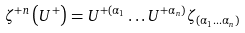<formula> <loc_0><loc_0><loc_500><loc_500>\zeta ^ { + n } \left ( U ^ { + } \right ) = U ^ { + ( \alpha _ { 1 } } \dots U ^ { + \alpha _ { n } ) } \zeta _ { \left ( \alpha _ { 1 } \dots \alpha _ { n } \right ) }</formula> 